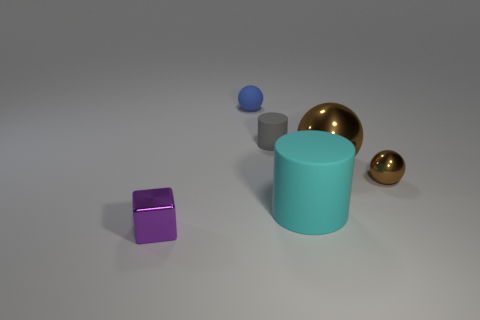Add 3 tiny purple metallic things. How many objects exist? 9 Subtract all cylinders. How many objects are left? 4 Subtract 0 purple balls. How many objects are left? 6 Subtract all tiny purple objects. Subtract all small blue things. How many objects are left? 4 Add 2 small rubber cylinders. How many small rubber cylinders are left? 3 Add 5 cyan things. How many cyan things exist? 6 